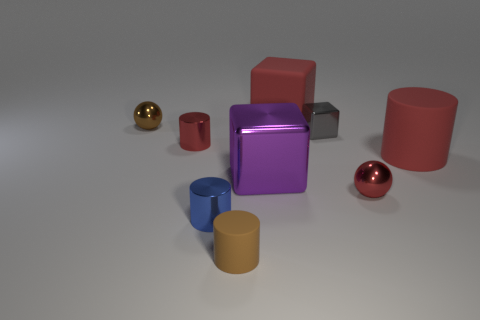Add 1 red matte cylinders. How many objects exist? 10 Subtract all cylinders. How many objects are left? 5 Subtract 0 green cylinders. How many objects are left? 9 Subtract all gray shiny balls. Subtract all purple metal objects. How many objects are left? 8 Add 9 small rubber cylinders. How many small rubber cylinders are left? 10 Add 4 big cubes. How many big cubes exist? 6 